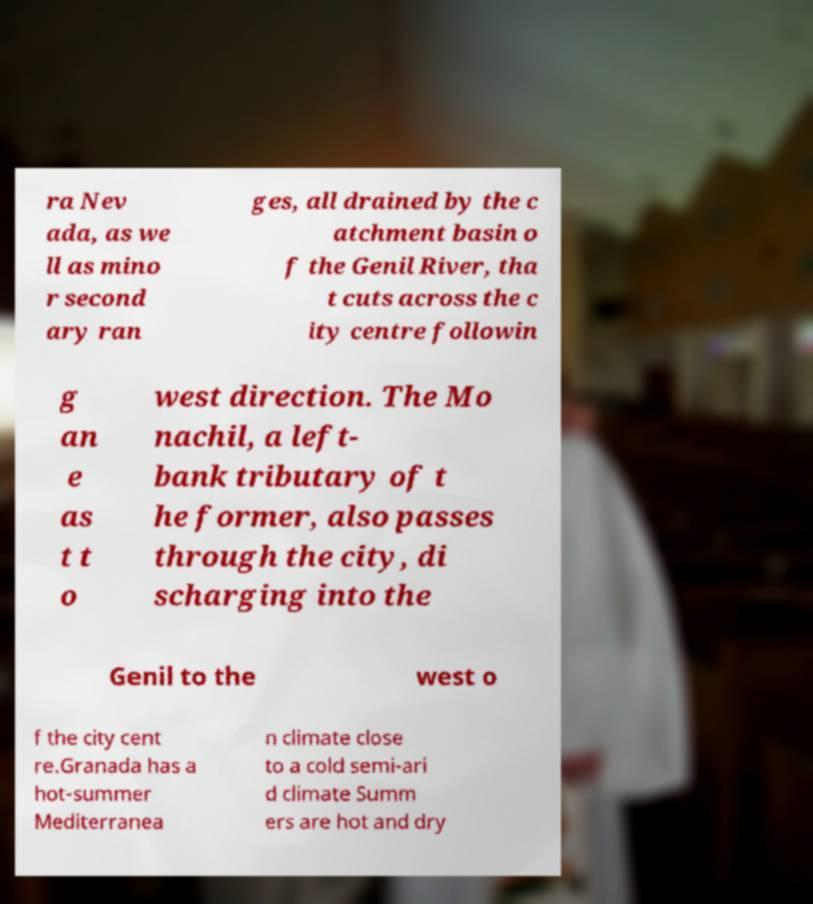Could you assist in decoding the text presented in this image and type it out clearly? ra Nev ada, as we ll as mino r second ary ran ges, all drained by the c atchment basin o f the Genil River, tha t cuts across the c ity centre followin g an e as t t o west direction. The Mo nachil, a left- bank tributary of t he former, also passes through the city, di scharging into the Genil to the west o f the city cent re.Granada has a hot-summer Mediterranea n climate close to a cold semi-ari d climate Summ ers are hot and dry 